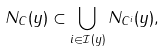Convert formula to latex. <formula><loc_0><loc_0><loc_500><loc_500>N _ { C } ( y ) \subset \bigcup _ { i \in \mathcal { I } ( y ) } N _ { C ^ { i } } ( y ) ,</formula> 